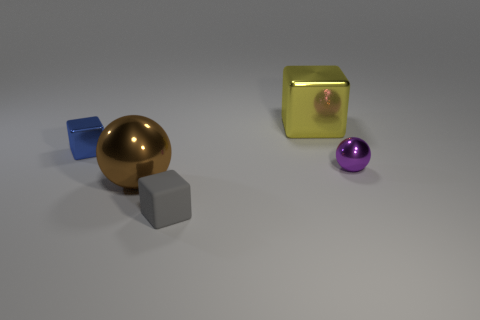Are there any large blocks left of the large yellow metallic cube?
Your answer should be compact. No. What number of other objects are there of the same shape as the large brown thing?
Your answer should be very brief. 1. The metallic ball that is the same size as the gray object is what color?
Offer a very short reply. Purple. Are there fewer yellow things that are in front of the purple metallic sphere than yellow things to the left of the big yellow object?
Offer a very short reply. No. There is a tiny metal thing that is left of the cube that is behind the blue metal block; what number of purple shiny objects are to the right of it?
Ensure brevity in your answer.  1. There is another metallic thing that is the same shape as the brown metal thing; what is its size?
Make the answer very short. Small. Is the number of tiny blue shiny cubes that are in front of the gray thing less than the number of small metal spheres?
Keep it short and to the point. Yes. Is the shape of the small purple shiny object the same as the rubber object?
Offer a very short reply. No. What color is the small matte object that is the same shape as the large yellow object?
Offer a terse response. Gray. How many things are either big things in front of the yellow thing or tiny cyan cubes?
Your answer should be very brief. 1. 